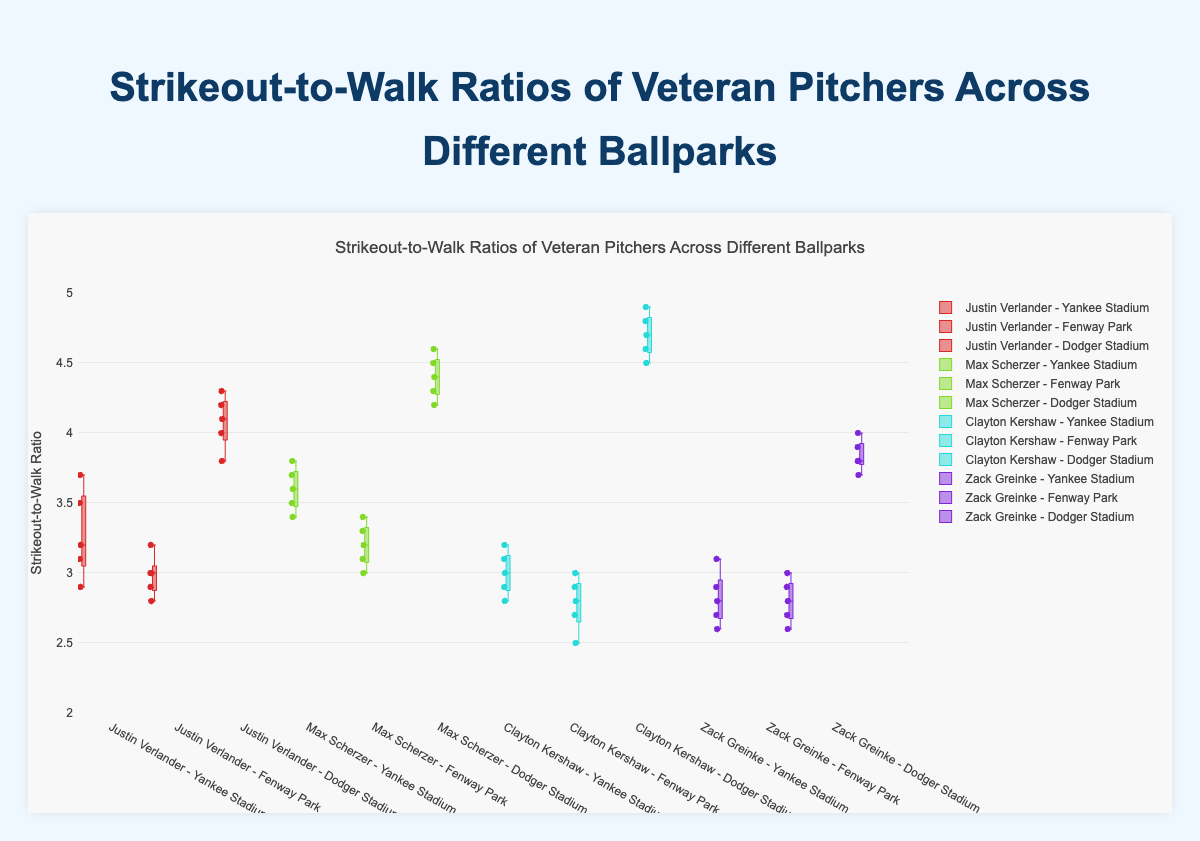What is the title of the chart? The title of the chart is located at the top and describes the overall content of the figure.
Answer: Strikeout-to-Walk Ratios of Veteran Pitchers Across Different Ballparks How many pitchers' data are displayed in the figure? Count the unique names of the pitchers listed in the legend or identified in each box plot.
Answer: 4 Which ballpark shows the highest Strikeout-to-Walk ratios for Clayton Kershaw? Examine the box plots for Clayton Kershaw at different ballparks and identify the one with the highest values.
Answer: Dodger Stadium What is the range of Strikeout-to-Walk ratios for Justin Verlander at Yankee Stadium? Find the minimum and maximum values in the box plot for Justin Verlander at Yankee Stadium. The range is the difference between these values.
Answer: [2.9, 3.7] Which pitcher has the most consistent Strikeout-to-Walk ratios at Fenway Park? Look at the spread (interquartile range) of the box plots for each pitcher at Fenway Park. The most consistent ratios will have the smallest spread.
Answer: Justin Verlander What’s the median Strikeout-to-Walk ratio for Max Scherzer at Dodger Stadium? The median value is represented by the line inside the box in the box plot for Max Scherzer at Dodger Stadium.
Answer: 4.4 Compare the median Strikeout-to-Walk ratios for all pitchers at Yankee Stadium. Who has the highest median? Identify the medians for each pitcher at Yankee Stadium by observing the lines inside each box plot and compare them.
Answer: Max Scherzer What is the interquartile range (IQR) for Zack Greinke at Fenway Park? The IQR is the difference between the upper quartile (Q3) and the lower quartile (Q1) values shown in the box plot for Zack Greinke at Fenway Park.
Answer: 0.3 (3.0 - 2.7) Which pitcher shows the greatest variation in Strikeout-to-Walk ratios at Dodger Stadium? Identify which box plot at Dodger Stadium has the largest overall spread or range from minimum to maximum values.
Answer: Clayton Kershaw In which ballpark does Max Scherzer have the narrowest interquartile range for Strikeout-to-Walk ratios? Evaluate the interquartile ranges (IQR) by examining the box plots for Max Scherzer at each ballpark and identify the smallest IQR.
Answer: Fenway Park 